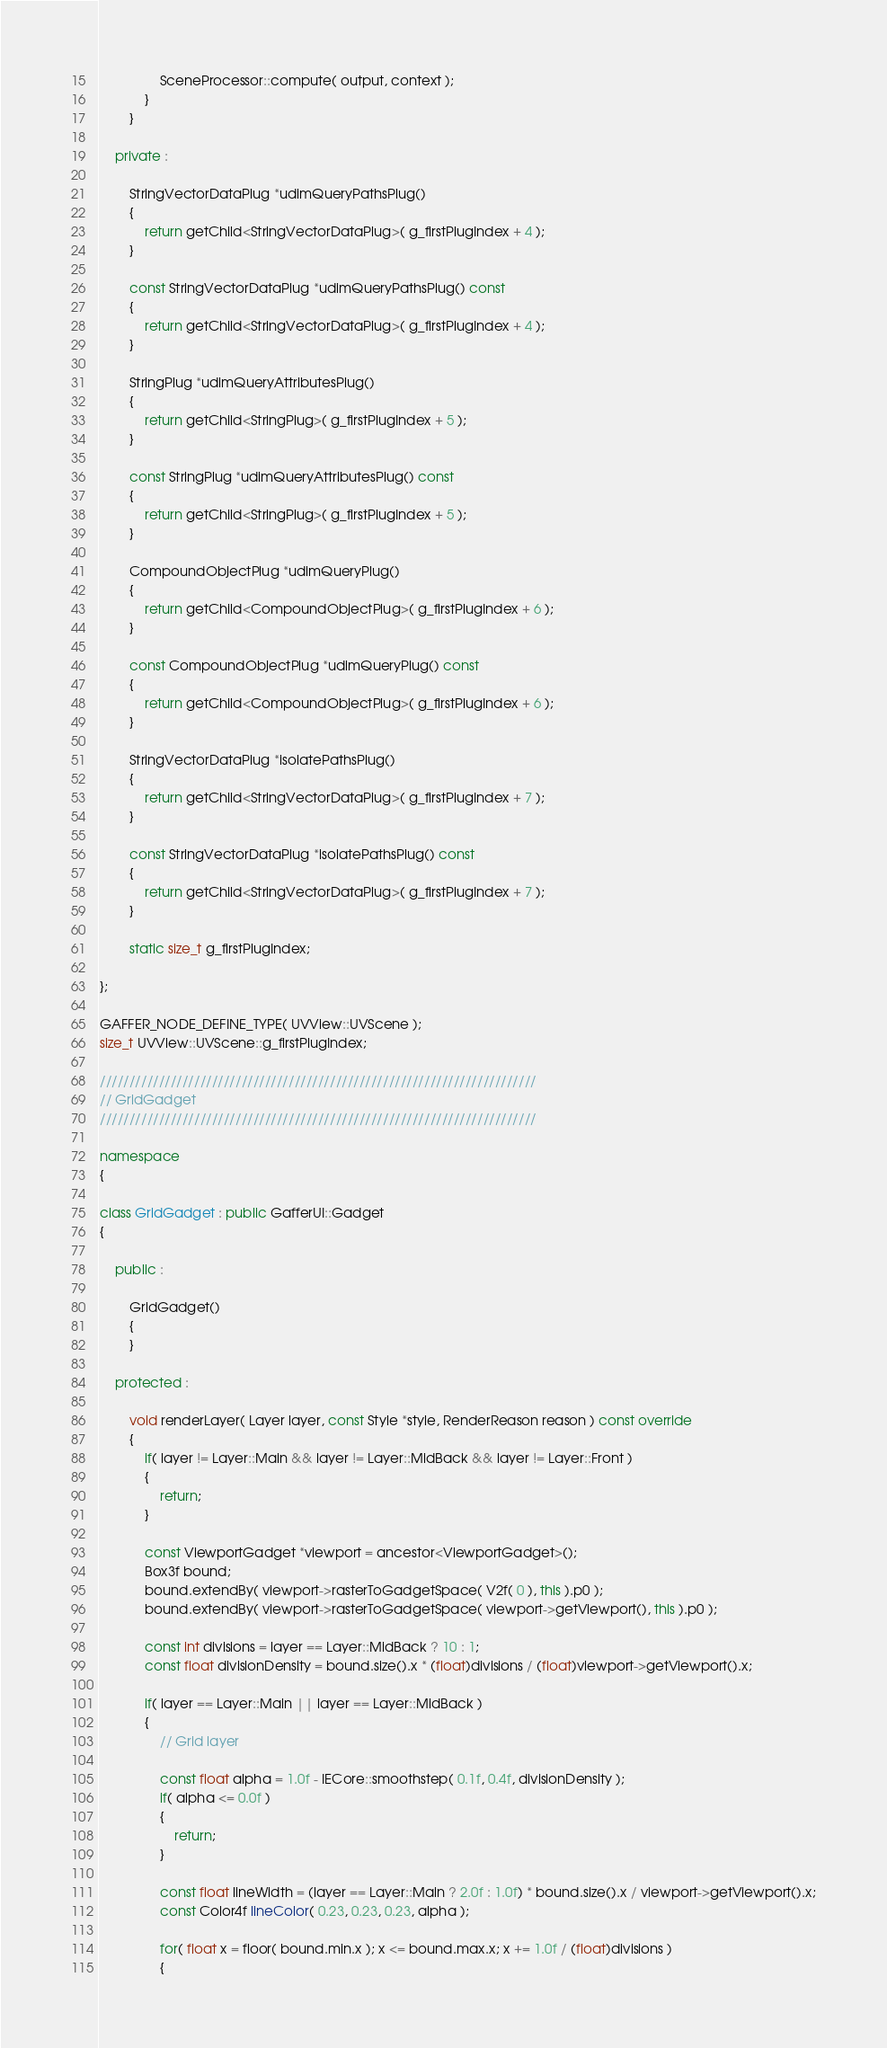<code> <loc_0><loc_0><loc_500><loc_500><_C++_>				SceneProcessor::compute( output, context );
			}
		}

	private :

		StringVectorDataPlug *udimQueryPathsPlug()
		{
			return getChild<StringVectorDataPlug>( g_firstPlugIndex + 4 );
		}

		const StringVectorDataPlug *udimQueryPathsPlug() const
		{
			return getChild<StringVectorDataPlug>( g_firstPlugIndex + 4 );
		}

		StringPlug *udimQueryAttributesPlug()
		{
			return getChild<StringPlug>( g_firstPlugIndex + 5 );
		}

		const StringPlug *udimQueryAttributesPlug() const
		{
			return getChild<StringPlug>( g_firstPlugIndex + 5 );
		}

		CompoundObjectPlug *udimQueryPlug()
		{
			return getChild<CompoundObjectPlug>( g_firstPlugIndex + 6 );
		}

		const CompoundObjectPlug *udimQueryPlug() const
		{
			return getChild<CompoundObjectPlug>( g_firstPlugIndex + 6 );
		}

		StringVectorDataPlug *isolatePathsPlug()
		{
			return getChild<StringVectorDataPlug>( g_firstPlugIndex + 7 );
		}

		const StringVectorDataPlug *isolatePathsPlug() const
		{
			return getChild<StringVectorDataPlug>( g_firstPlugIndex + 7 );
		}

		static size_t g_firstPlugIndex;

};

GAFFER_NODE_DEFINE_TYPE( UVView::UVScene );
size_t UVView::UVScene::g_firstPlugIndex;

//////////////////////////////////////////////////////////////////////////
// GridGadget
//////////////////////////////////////////////////////////////////////////

namespace
{

class GridGadget : public GafferUI::Gadget
{

	public :

		GridGadget()
		{
		}

	protected :

		void renderLayer( Layer layer, const Style *style, RenderReason reason ) const override
		{
			if( layer != Layer::Main && layer != Layer::MidBack && layer != Layer::Front )
			{
				return;
			}

			const ViewportGadget *viewport = ancestor<ViewportGadget>();
			Box3f bound;
			bound.extendBy( viewport->rasterToGadgetSpace( V2f( 0 ), this ).p0 );
			bound.extendBy( viewport->rasterToGadgetSpace( viewport->getViewport(), this ).p0 );

			const int divisions = layer == Layer::MidBack ? 10 : 1;
			const float divisionDensity = bound.size().x * (float)divisions / (float)viewport->getViewport().x;

			if( layer == Layer::Main || layer == Layer::MidBack )
			{
				// Grid layer

				const float alpha = 1.0f - IECore::smoothstep( 0.1f, 0.4f, divisionDensity );
				if( alpha <= 0.0f )
				{
					return;
				}

				const float lineWidth = (layer == Layer::Main ? 2.0f : 1.0f) * bound.size().x / viewport->getViewport().x;
				const Color4f lineColor( 0.23, 0.23, 0.23, alpha );

				for( float x = floor( bound.min.x ); x <= bound.max.x; x += 1.0f / (float)divisions )
				{</code> 